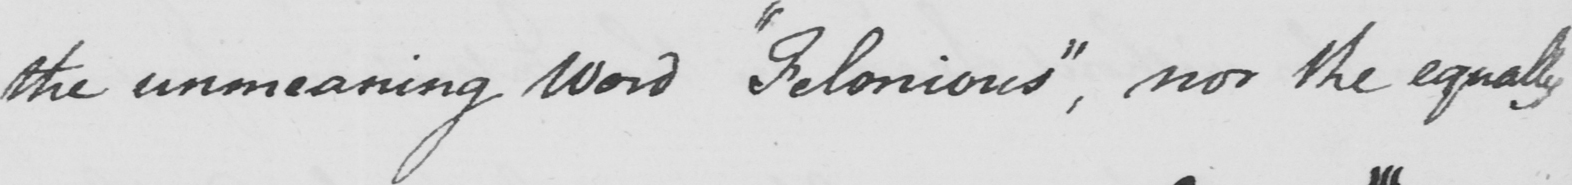Please transcribe the handwritten text in this image. the unmeaning Word  " Felonious "  , nor the equally 